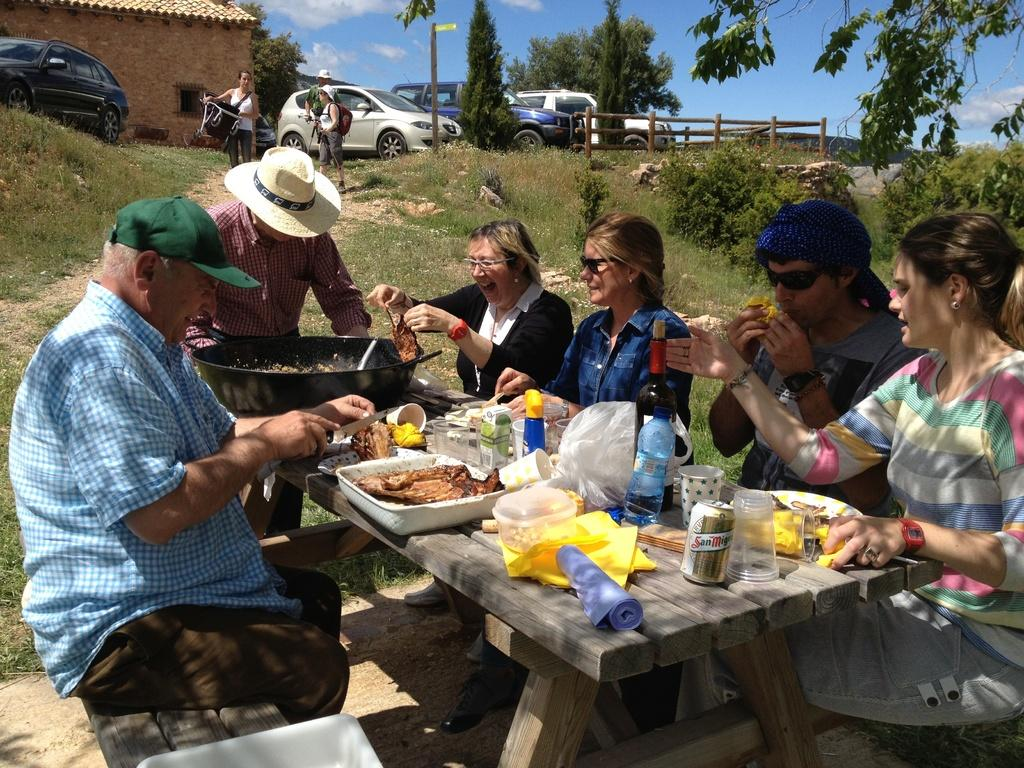What are the people in the image doing? The people in the image are sitting on chairs and eating food. Who is serving the food? One person is serving food in the image. What type of structure is present in the image? There is a hut in the image. What can be seen in the background of the image? Cars are parked in the image. What word is written on the cave in the image? There is no cave present in the image, so no word can be written on it. How does the person fall from the chair in the image? There is no person falling from a chair in the image. 